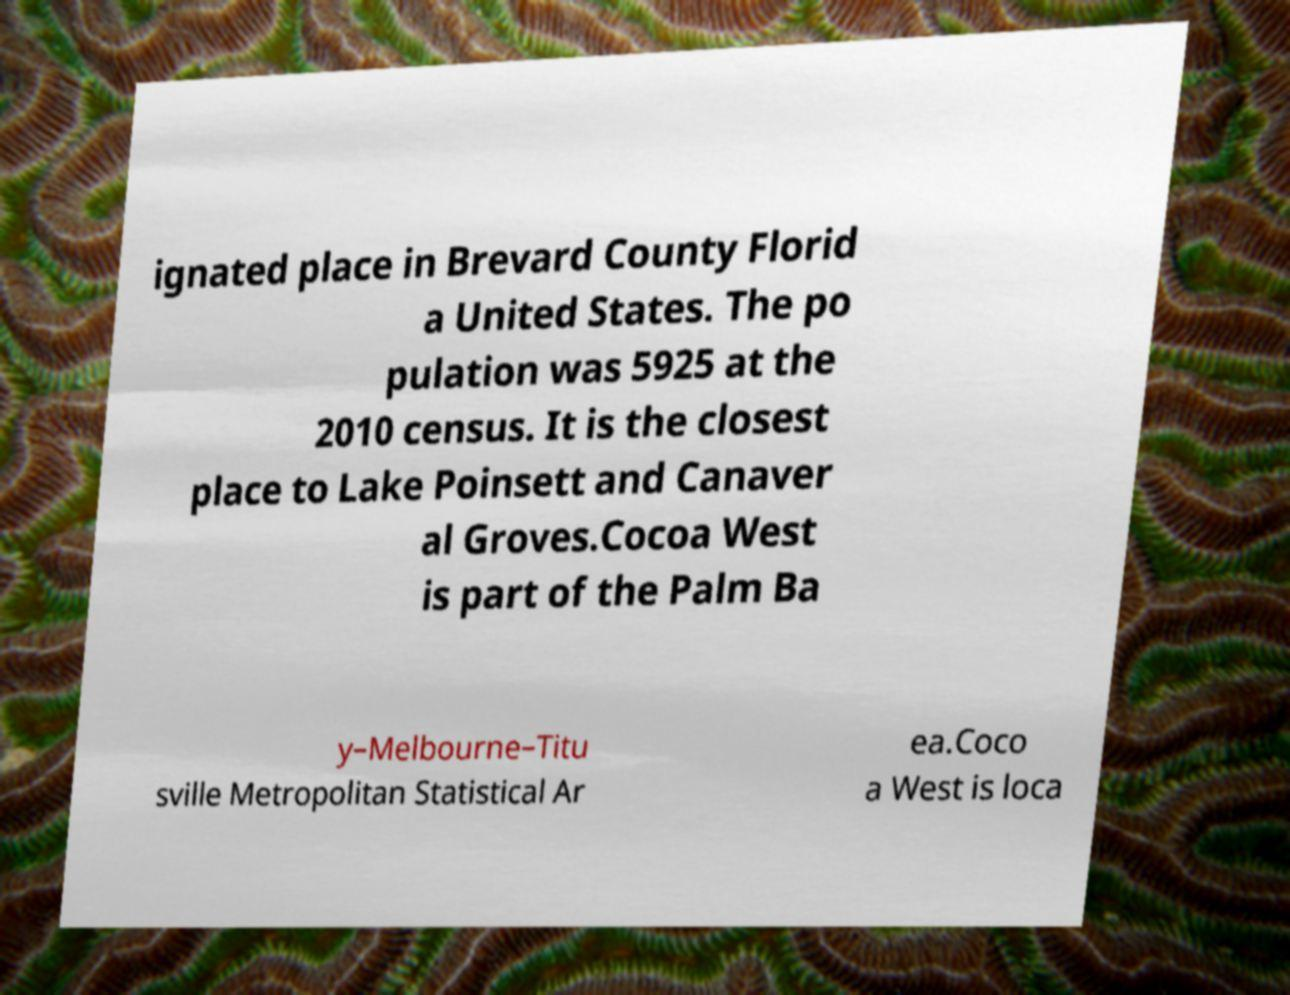For documentation purposes, I need the text within this image transcribed. Could you provide that? ignated place in Brevard County Florid a United States. The po pulation was 5925 at the 2010 census. It is the closest place to Lake Poinsett and Canaver al Groves.Cocoa West is part of the Palm Ba y–Melbourne–Titu sville Metropolitan Statistical Ar ea.Coco a West is loca 